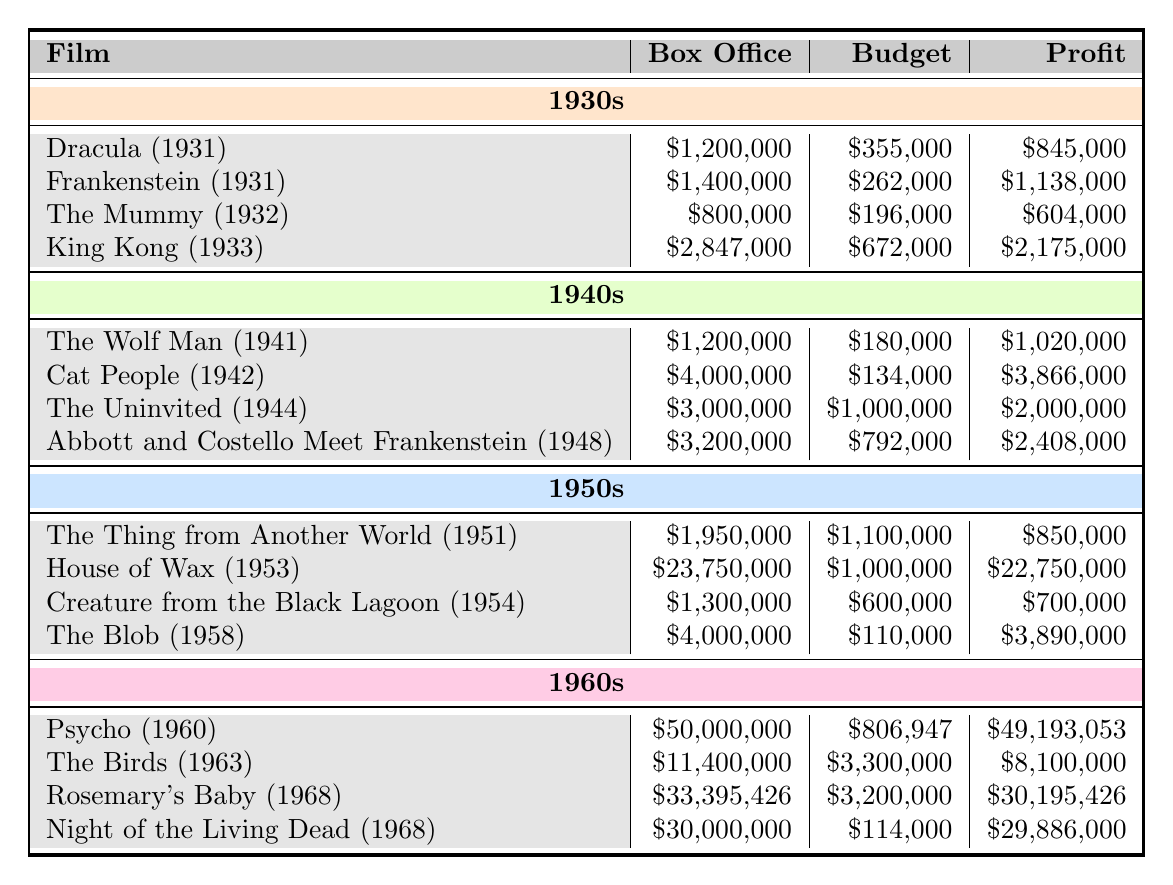What is the box office earnings of "Dracula (1931)"? The box office earnings for "Dracula (1931)" is directly given in the table, listed under its name in the 1930s section. It shows $1,200,000.
Answer: $1,200,000 Which film had the highest profit in the 1940s? By comparing the profit values listed for each film in the 1940s section, "Cat People (1942)" has the highest profit of $3,866,000.
Answer: Cat People (1942) What is the total box office earnings of all films from the 1950s? The films in the 1950s are listed with their respective box office earnings. Summing them gives: $1,950,000 + $23,750,000 + $1,300,000 + $4,000,000 = $30,000,000.
Answer: $30,000,000 Did "Night of the Living Dead (1968)" have a budget greater than $200,000? The budget for "Night of the Living Dead (1968)" is $114,000, which is less than $200,000. Hence, the answer is no.
Answer: No Which decade had the highest total profit across all its films? First, calculate the total profit for each decade: 1930s: $845,000 + $1,138,000 + $604,000 + $2,175,000 = $4,762,000; 1940s: $1,020,000 + $3,866,000 + $2,000,000 + $2,408,000 = $9,294,000; 1950s: $850,000 + $22,750,000 + $700,000 + $3,890,000 = $28,190,000; 1960s: $49,193,053 + $8,100,000 + $30,195,426 + $29,886,000 = $117,374,479. The 1960s had the highest total profit, with $117,374,479.
Answer: 1960s What is the average budget for films from the 1930s? The budgets for the 1930s films are $355,000, $262,000, $196,000, and $672,000. To find the average, sum these values: $355,000 + $262,000 + $196,000 + $672,000 = $1,485,000. Then divide by the number of films, which is 4: $1,485,000 / 4 = $371,250.
Answer: $371,250 